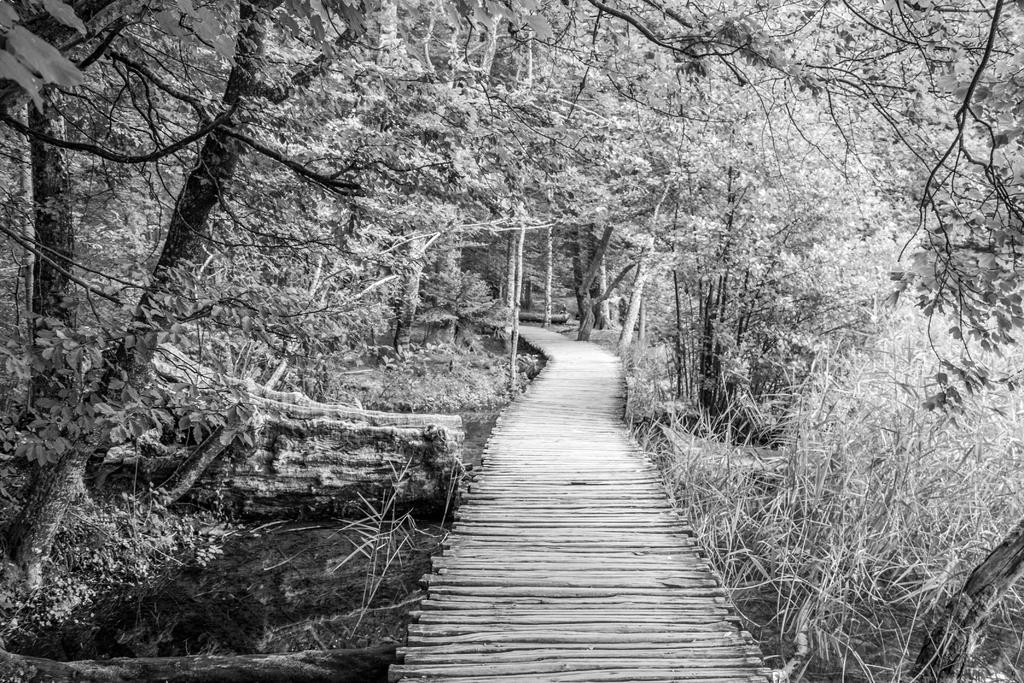What is the main feature of the image? There is a path in the image. What can be seen alongside the path? There are trees visible in the image. What is the color scheme of the image? The image is black and white in color. What type of oatmeal is being served on the chair in the image? There is no oatmeal or chair present in the image; it only features a path and trees. 